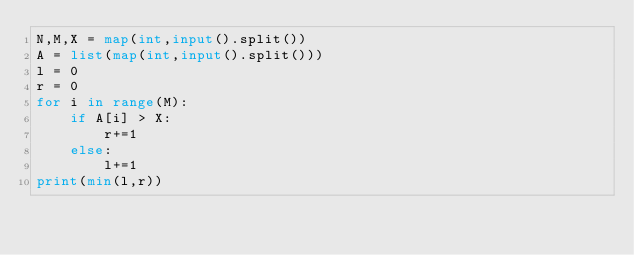Convert code to text. <code><loc_0><loc_0><loc_500><loc_500><_Python_>N,M,X = map(int,input().split())
A = list(map(int,input().split()))
l = 0
r = 0
for i in range(M):
    if A[i] > X:
        r+=1
    else:
        l+=1
print(min(l,r))</code> 